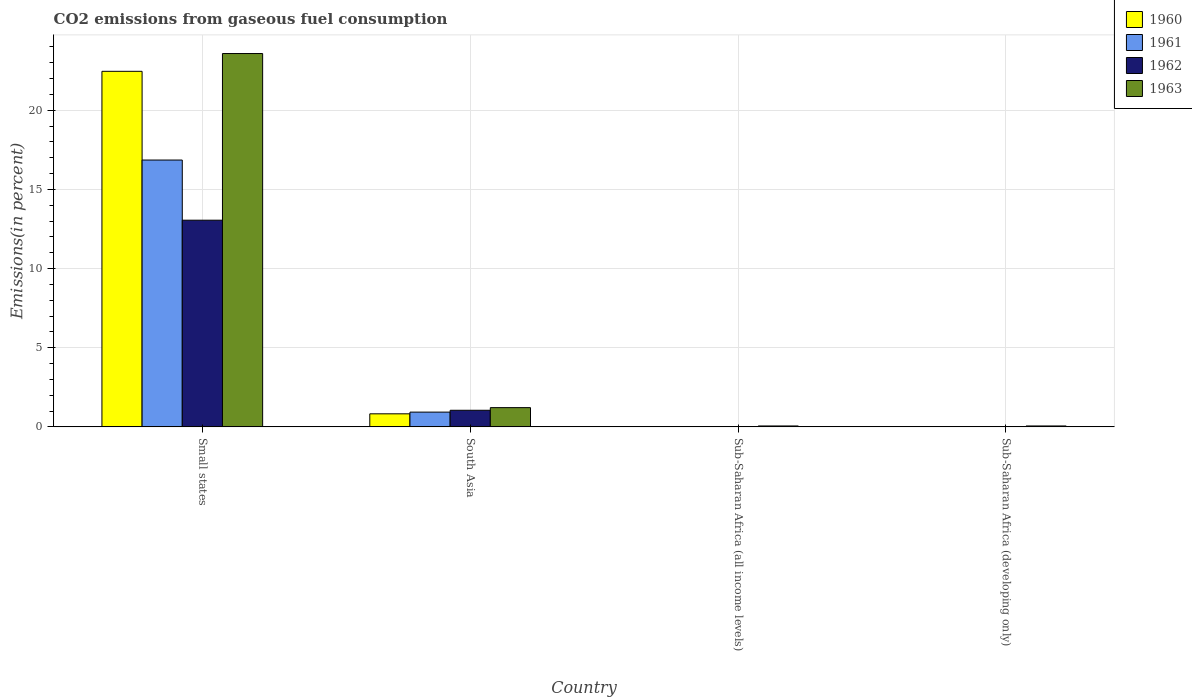How many different coloured bars are there?
Provide a short and direct response. 4. How many groups of bars are there?
Give a very brief answer. 4. Are the number of bars on each tick of the X-axis equal?
Your response must be concise. Yes. How many bars are there on the 2nd tick from the left?
Make the answer very short. 4. What is the label of the 1st group of bars from the left?
Your answer should be very brief. Small states. In how many cases, is the number of bars for a given country not equal to the number of legend labels?
Offer a terse response. 0. What is the total CO2 emitted in 1962 in Small states?
Provide a succinct answer. 13.06. Across all countries, what is the maximum total CO2 emitted in 1963?
Give a very brief answer. 23.59. Across all countries, what is the minimum total CO2 emitted in 1961?
Offer a very short reply. 0.01. In which country was the total CO2 emitted in 1960 maximum?
Keep it short and to the point. Small states. In which country was the total CO2 emitted in 1963 minimum?
Give a very brief answer. Sub-Saharan Africa (all income levels). What is the total total CO2 emitted in 1963 in the graph?
Your answer should be compact. 24.92. What is the difference between the total CO2 emitted in 1960 in South Asia and that in Sub-Saharan Africa (all income levels)?
Give a very brief answer. 0.81. What is the difference between the total CO2 emitted in 1961 in Sub-Saharan Africa (all income levels) and the total CO2 emitted in 1960 in Small states?
Offer a very short reply. -22.45. What is the average total CO2 emitted in 1961 per country?
Offer a terse response. 4.45. What is the difference between the total CO2 emitted of/in 1962 and total CO2 emitted of/in 1960 in Sub-Saharan Africa (developing only)?
Make the answer very short. 0. In how many countries, is the total CO2 emitted in 1962 greater than 13 %?
Offer a terse response. 1. What is the ratio of the total CO2 emitted in 1961 in Small states to that in Sub-Saharan Africa (all income levels)?
Provide a succinct answer. 1414.45. Is the difference between the total CO2 emitted in 1962 in South Asia and Sub-Saharan Africa (developing only) greater than the difference between the total CO2 emitted in 1960 in South Asia and Sub-Saharan Africa (developing only)?
Offer a very short reply. Yes. What is the difference between the highest and the second highest total CO2 emitted in 1960?
Keep it short and to the point. 0.81. What is the difference between the highest and the lowest total CO2 emitted in 1961?
Provide a succinct answer. 16.85. In how many countries, is the total CO2 emitted in 1962 greater than the average total CO2 emitted in 1962 taken over all countries?
Your response must be concise. 1. What does the 3rd bar from the left in Sub-Saharan Africa (all income levels) represents?
Provide a succinct answer. 1962. What does the 4th bar from the right in South Asia represents?
Offer a terse response. 1960. Is it the case that in every country, the sum of the total CO2 emitted in 1963 and total CO2 emitted in 1961 is greater than the total CO2 emitted in 1960?
Your answer should be very brief. Yes. How many bars are there?
Make the answer very short. 16. Does the graph contain any zero values?
Provide a succinct answer. No. Does the graph contain grids?
Your answer should be very brief. Yes. Where does the legend appear in the graph?
Ensure brevity in your answer.  Top right. What is the title of the graph?
Provide a short and direct response. CO2 emissions from gaseous fuel consumption. Does "1971" appear as one of the legend labels in the graph?
Offer a terse response. No. What is the label or title of the X-axis?
Give a very brief answer. Country. What is the label or title of the Y-axis?
Ensure brevity in your answer.  Emissions(in percent). What is the Emissions(in percent) in 1960 in Small states?
Your response must be concise. 22.46. What is the Emissions(in percent) in 1961 in Small states?
Keep it short and to the point. 16.86. What is the Emissions(in percent) of 1962 in Small states?
Provide a succinct answer. 13.06. What is the Emissions(in percent) of 1963 in Small states?
Offer a very short reply. 23.59. What is the Emissions(in percent) of 1960 in South Asia?
Provide a short and direct response. 0.82. What is the Emissions(in percent) of 1961 in South Asia?
Provide a short and direct response. 0.93. What is the Emissions(in percent) of 1962 in South Asia?
Your response must be concise. 1.05. What is the Emissions(in percent) in 1963 in South Asia?
Your response must be concise. 1.22. What is the Emissions(in percent) in 1960 in Sub-Saharan Africa (all income levels)?
Offer a terse response. 0.01. What is the Emissions(in percent) of 1961 in Sub-Saharan Africa (all income levels)?
Your answer should be compact. 0.01. What is the Emissions(in percent) in 1962 in Sub-Saharan Africa (all income levels)?
Provide a short and direct response. 0.01. What is the Emissions(in percent) in 1963 in Sub-Saharan Africa (all income levels)?
Provide a short and direct response. 0.06. What is the Emissions(in percent) of 1960 in Sub-Saharan Africa (developing only)?
Give a very brief answer. 0.01. What is the Emissions(in percent) of 1961 in Sub-Saharan Africa (developing only)?
Provide a succinct answer. 0.01. What is the Emissions(in percent) of 1962 in Sub-Saharan Africa (developing only)?
Provide a short and direct response. 0.01. What is the Emissions(in percent) in 1963 in Sub-Saharan Africa (developing only)?
Your response must be concise. 0.06. Across all countries, what is the maximum Emissions(in percent) in 1960?
Give a very brief answer. 22.46. Across all countries, what is the maximum Emissions(in percent) of 1961?
Your answer should be compact. 16.86. Across all countries, what is the maximum Emissions(in percent) in 1962?
Keep it short and to the point. 13.06. Across all countries, what is the maximum Emissions(in percent) in 1963?
Ensure brevity in your answer.  23.59. Across all countries, what is the minimum Emissions(in percent) in 1960?
Your answer should be compact. 0.01. Across all countries, what is the minimum Emissions(in percent) in 1961?
Provide a succinct answer. 0.01. Across all countries, what is the minimum Emissions(in percent) of 1962?
Make the answer very short. 0.01. Across all countries, what is the minimum Emissions(in percent) in 1963?
Keep it short and to the point. 0.06. What is the total Emissions(in percent) in 1960 in the graph?
Ensure brevity in your answer.  23.31. What is the total Emissions(in percent) in 1961 in the graph?
Offer a very short reply. 17.81. What is the total Emissions(in percent) in 1962 in the graph?
Give a very brief answer. 14.13. What is the total Emissions(in percent) of 1963 in the graph?
Your answer should be very brief. 24.92. What is the difference between the Emissions(in percent) of 1960 in Small states and that in South Asia?
Give a very brief answer. 21.64. What is the difference between the Emissions(in percent) in 1961 in Small states and that in South Asia?
Give a very brief answer. 15.93. What is the difference between the Emissions(in percent) in 1962 in Small states and that in South Asia?
Offer a very short reply. 12.01. What is the difference between the Emissions(in percent) of 1963 in Small states and that in South Asia?
Your answer should be compact. 22.37. What is the difference between the Emissions(in percent) of 1960 in Small states and that in Sub-Saharan Africa (all income levels)?
Your answer should be compact. 22.45. What is the difference between the Emissions(in percent) in 1961 in Small states and that in Sub-Saharan Africa (all income levels)?
Your answer should be compact. 16.85. What is the difference between the Emissions(in percent) in 1962 in Small states and that in Sub-Saharan Africa (all income levels)?
Keep it short and to the point. 13.04. What is the difference between the Emissions(in percent) of 1963 in Small states and that in Sub-Saharan Africa (all income levels)?
Ensure brevity in your answer.  23.53. What is the difference between the Emissions(in percent) in 1960 in Small states and that in Sub-Saharan Africa (developing only)?
Your answer should be very brief. 22.45. What is the difference between the Emissions(in percent) of 1961 in Small states and that in Sub-Saharan Africa (developing only)?
Provide a short and direct response. 16.85. What is the difference between the Emissions(in percent) of 1962 in Small states and that in Sub-Saharan Africa (developing only)?
Ensure brevity in your answer.  13.04. What is the difference between the Emissions(in percent) of 1963 in Small states and that in Sub-Saharan Africa (developing only)?
Provide a short and direct response. 23.53. What is the difference between the Emissions(in percent) in 1960 in South Asia and that in Sub-Saharan Africa (all income levels)?
Provide a succinct answer. 0.81. What is the difference between the Emissions(in percent) in 1961 in South Asia and that in Sub-Saharan Africa (all income levels)?
Keep it short and to the point. 0.92. What is the difference between the Emissions(in percent) of 1962 in South Asia and that in Sub-Saharan Africa (all income levels)?
Offer a very short reply. 1.03. What is the difference between the Emissions(in percent) in 1963 in South Asia and that in Sub-Saharan Africa (all income levels)?
Ensure brevity in your answer.  1.16. What is the difference between the Emissions(in percent) in 1960 in South Asia and that in Sub-Saharan Africa (developing only)?
Offer a very short reply. 0.81. What is the difference between the Emissions(in percent) of 1961 in South Asia and that in Sub-Saharan Africa (developing only)?
Your answer should be compact. 0.92. What is the difference between the Emissions(in percent) of 1962 in South Asia and that in Sub-Saharan Africa (developing only)?
Ensure brevity in your answer.  1.03. What is the difference between the Emissions(in percent) in 1963 in South Asia and that in Sub-Saharan Africa (developing only)?
Ensure brevity in your answer.  1.16. What is the difference between the Emissions(in percent) of 1960 in Sub-Saharan Africa (all income levels) and that in Sub-Saharan Africa (developing only)?
Your answer should be very brief. -0. What is the difference between the Emissions(in percent) of 1962 in Sub-Saharan Africa (all income levels) and that in Sub-Saharan Africa (developing only)?
Offer a very short reply. -0. What is the difference between the Emissions(in percent) of 1960 in Small states and the Emissions(in percent) of 1961 in South Asia?
Keep it short and to the point. 21.53. What is the difference between the Emissions(in percent) in 1960 in Small states and the Emissions(in percent) in 1962 in South Asia?
Your response must be concise. 21.41. What is the difference between the Emissions(in percent) in 1960 in Small states and the Emissions(in percent) in 1963 in South Asia?
Provide a short and direct response. 21.25. What is the difference between the Emissions(in percent) in 1961 in Small states and the Emissions(in percent) in 1962 in South Asia?
Offer a terse response. 15.81. What is the difference between the Emissions(in percent) of 1961 in Small states and the Emissions(in percent) of 1963 in South Asia?
Your response must be concise. 15.64. What is the difference between the Emissions(in percent) in 1962 in Small states and the Emissions(in percent) in 1963 in South Asia?
Keep it short and to the point. 11.84. What is the difference between the Emissions(in percent) of 1960 in Small states and the Emissions(in percent) of 1961 in Sub-Saharan Africa (all income levels)?
Provide a succinct answer. 22.45. What is the difference between the Emissions(in percent) in 1960 in Small states and the Emissions(in percent) in 1962 in Sub-Saharan Africa (all income levels)?
Ensure brevity in your answer.  22.45. What is the difference between the Emissions(in percent) in 1960 in Small states and the Emissions(in percent) in 1963 in Sub-Saharan Africa (all income levels)?
Keep it short and to the point. 22.4. What is the difference between the Emissions(in percent) in 1961 in Small states and the Emissions(in percent) in 1962 in Sub-Saharan Africa (all income levels)?
Give a very brief answer. 16.84. What is the difference between the Emissions(in percent) of 1961 in Small states and the Emissions(in percent) of 1963 in Sub-Saharan Africa (all income levels)?
Your answer should be compact. 16.8. What is the difference between the Emissions(in percent) in 1962 in Small states and the Emissions(in percent) in 1963 in Sub-Saharan Africa (all income levels)?
Keep it short and to the point. 13. What is the difference between the Emissions(in percent) of 1960 in Small states and the Emissions(in percent) of 1961 in Sub-Saharan Africa (developing only)?
Provide a succinct answer. 22.45. What is the difference between the Emissions(in percent) of 1960 in Small states and the Emissions(in percent) of 1962 in Sub-Saharan Africa (developing only)?
Provide a short and direct response. 22.45. What is the difference between the Emissions(in percent) in 1960 in Small states and the Emissions(in percent) in 1963 in Sub-Saharan Africa (developing only)?
Provide a short and direct response. 22.4. What is the difference between the Emissions(in percent) of 1961 in Small states and the Emissions(in percent) of 1962 in Sub-Saharan Africa (developing only)?
Provide a succinct answer. 16.84. What is the difference between the Emissions(in percent) of 1961 in Small states and the Emissions(in percent) of 1963 in Sub-Saharan Africa (developing only)?
Give a very brief answer. 16.8. What is the difference between the Emissions(in percent) of 1962 in Small states and the Emissions(in percent) of 1963 in Sub-Saharan Africa (developing only)?
Keep it short and to the point. 13. What is the difference between the Emissions(in percent) of 1960 in South Asia and the Emissions(in percent) of 1961 in Sub-Saharan Africa (all income levels)?
Provide a succinct answer. 0.81. What is the difference between the Emissions(in percent) in 1960 in South Asia and the Emissions(in percent) in 1962 in Sub-Saharan Africa (all income levels)?
Ensure brevity in your answer.  0.81. What is the difference between the Emissions(in percent) of 1960 in South Asia and the Emissions(in percent) of 1963 in Sub-Saharan Africa (all income levels)?
Your answer should be compact. 0.77. What is the difference between the Emissions(in percent) of 1961 in South Asia and the Emissions(in percent) of 1962 in Sub-Saharan Africa (all income levels)?
Your answer should be very brief. 0.92. What is the difference between the Emissions(in percent) in 1961 in South Asia and the Emissions(in percent) in 1963 in Sub-Saharan Africa (all income levels)?
Your answer should be very brief. 0.87. What is the difference between the Emissions(in percent) in 1962 in South Asia and the Emissions(in percent) in 1963 in Sub-Saharan Africa (all income levels)?
Offer a very short reply. 0.99. What is the difference between the Emissions(in percent) in 1960 in South Asia and the Emissions(in percent) in 1961 in Sub-Saharan Africa (developing only)?
Provide a succinct answer. 0.81. What is the difference between the Emissions(in percent) of 1960 in South Asia and the Emissions(in percent) of 1962 in Sub-Saharan Africa (developing only)?
Ensure brevity in your answer.  0.81. What is the difference between the Emissions(in percent) of 1960 in South Asia and the Emissions(in percent) of 1963 in Sub-Saharan Africa (developing only)?
Give a very brief answer. 0.77. What is the difference between the Emissions(in percent) of 1961 in South Asia and the Emissions(in percent) of 1962 in Sub-Saharan Africa (developing only)?
Make the answer very short. 0.92. What is the difference between the Emissions(in percent) in 1961 in South Asia and the Emissions(in percent) in 1963 in Sub-Saharan Africa (developing only)?
Make the answer very short. 0.87. What is the difference between the Emissions(in percent) in 1962 in South Asia and the Emissions(in percent) in 1963 in Sub-Saharan Africa (developing only)?
Ensure brevity in your answer.  0.99. What is the difference between the Emissions(in percent) in 1960 in Sub-Saharan Africa (all income levels) and the Emissions(in percent) in 1961 in Sub-Saharan Africa (developing only)?
Provide a succinct answer. 0. What is the difference between the Emissions(in percent) in 1960 in Sub-Saharan Africa (all income levels) and the Emissions(in percent) in 1962 in Sub-Saharan Africa (developing only)?
Your answer should be compact. -0. What is the difference between the Emissions(in percent) in 1960 in Sub-Saharan Africa (all income levels) and the Emissions(in percent) in 1963 in Sub-Saharan Africa (developing only)?
Provide a short and direct response. -0.05. What is the difference between the Emissions(in percent) of 1961 in Sub-Saharan Africa (all income levels) and the Emissions(in percent) of 1962 in Sub-Saharan Africa (developing only)?
Offer a terse response. -0. What is the difference between the Emissions(in percent) of 1961 in Sub-Saharan Africa (all income levels) and the Emissions(in percent) of 1963 in Sub-Saharan Africa (developing only)?
Offer a very short reply. -0.05. What is the difference between the Emissions(in percent) in 1962 in Sub-Saharan Africa (all income levels) and the Emissions(in percent) in 1963 in Sub-Saharan Africa (developing only)?
Ensure brevity in your answer.  -0.04. What is the average Emissions(in percent) in 1960 per country?
Offer a very short reply. 5.83. What is the average Emissions(in percent) in 1961 per country?
Your response must be concise. 4.45. What is the average Emissions(in percent) of 1962 per country?
Make the answer very short. 3.53. What is the average Emissions(in percent) of 1963 per country?
Your answer should be compact. 6.23. What is the difference between the Emissions(in percent) of 1960 and Emissions(in percent) of 1961 in Small states?
Provide a short and direct response. 5.6. What is the difference between the Emissions(in percent) of 1960 and Emissions(in percent) of 1962 in Small states?
Your answer should be very brief. 9.41. What is the difference between the Emissions(in percent) of 1960 and Emissions(in percent) of 1963 in Small states?
Keep it short and to the point. -1.12. What is the difference between the Emissions(in percent) of 1961 and Emissions(in percent) of 1962 in Small states?
Make the answer very short. 3.8. What is the difference between the Emissions(in percent) of 1961 and Emissions(in percent) of 1963 in Small states?
Offer a terse response. -6.73. What is the difference between the Emissions(in percent) in 1962 and Emissions(in percent) in 1963 in Small states?
Your response must be concise. -10.53. What is the difference between the Emissions(in percent) in 1960 and Emissions(in percent) in 1961 in South Asia?
Your response must be concise. -0.11. What is the difference between the Emissions(in percent) of 1960 and Emissions(in percent) of 1962 in South Asia?
Your answer should be compact. -0.22. What is the difference between the Emissions(in percent) of 1960 and Emissions(in percent) of 1963 in South Asia?
Offer a very short reply. -0.39. What is the difference between the Emissions(in percent) of 1961 and Emissions(in percent) of 1962 in South Asia?
Ensure brevity in your answer.  -0.12. What is the difference between the Emissions(in percent) of 1961 and Emissions(in percent) of 1963 in South Asia?
Offer a terse response. -0.28. What is the difference between the Emissions(in percent) in 1962 and Emissions(in percent) in 1963 in South Asia?
Your answer should be very brief. -0.17. What is the difference between the Emissions(in percent) of 1960 and Emissions(in percent) of 1961 in Sub-Saharan Africa (all income levels)?
Your answer should be very brief. 0. What is the difference between the Emissions(in percent) of 1960 and Emissions(in percent) of 1962 in Sub-Saharan Africa (all income levels)?
Keep it short and to the point. -0. What is the difference between the Emissions(in percent) of 1960 and Emissions(in percent) of 1963 in Sub-Saharan Africa (all income levels)?
Provide a succinct answer. -0.05. What is the difference between the Emissions(in percent) in 1961 and Emissions(in percent) in 1962 in Sub-Saharan Africa (all income levels)?
Make the answer very short. -0. What is the difference between the Emissions(in percent) of 1961 and Emissions(in percent) of 1963 in Sub-Saharan Africa (all income levels)?
Give a very brief answer. -0.05. What is the difference between the Emissions(in percent) in 1962 and Emissions(in percent) in 1963 in Sub-Saharan Africa (all income levels)?
Your answer should be compact. -0.04. What is the difference between the Emissions(in percent) in 1960 and Emissions(in percent) in 1962 in Sub-Saharan Africa (developing only)?
Your answer should be very brief. -0. What is the difference between the Emissions(in percent) in 1960 and Emissions(in percent) in 1963 in Sub-Saharan Africa (developing only)?
Your answer should be compact. -0.05. What is the difference between the Emissions(in percent) in 1961 and Emissions(in percent) in 1962 in Sub-Saharan Africa (developing only)?
Give a very brief answer. -0. What is the difference between the Emissions(in percent) of 1961 and Emissions(in percent) of 1963 in Sub-Saharan Africa (developing only)?
Give a very brief answer. -0.05. What is the difference between the Emissions(in percent) of 1962 and Emissions(in percent) of 1963 in Sub-Saharan Africa (developing only)?
Offer a very short reply. -0.04. What is the ratio of the Emissions(in percent) of 1960 in Small states to that in South Asia?
Offer a very short reply. 27.26. What is the ratio of the Emissions(in percent) of 1961 in Small states to that in South Asia?
Your response must be concise. 18.09. What is the ratio of the Emissions(in percent) of 1962 in Small states to that in South Asia?
Your answer should be compact. 12.45. What is the ratio of the Emissions(in percent) of 1963 in Small states to that in South Asia?
Make the answer very short. 19.41. What is the ratio of the Emissions(in percent) in 1960 in Small states to that in Sub-Saharan Africa (all income levels)?
Offer a terse response. 1801.95. What is the ratio of the Emissions(in percent) in 1961 in Small states to that in Sub-Saharan Africa (all income levels)?
Make the answer very short. 1414.45. What is the ratio of the Emissions(in percent) of 1962 in Small states to that in Sub-Saharan Africa (all income levels)?
Ensure brevity in your answer.  907.48. What is the ratio of the Emissions(in percent) in 1963 in Small states to that in Sub-Saharan Africa (all income levels)?
Provide a short and direct response. 409.19. What is the ratio of the Emissions(in percent) in 1960 in Small states to that in Sub-Saharan Africa (developing only)?
Ensure brevity in your answer.  1801.61. What is the ratio of the Emissions(in percent) of 1961 in Small states to that in Sub-Saharan Africa (developing only)?
Provide a succinct answer. 1414.2. What is the ratio of the Emissions(in percent) in 1962 in Small states to that in Sub-Saharan Africa (developing only)?
Make the answer very short. 907.33. What is the ratio of the Emissions(in percent) of 1963 in Small states to that in Sub-Saharan Africa (developing only)?
Your response must be concise. 409.09. What is the ratio of the Emissions(in percent) of 1960 in South Asia to that in Sub-Saharan Africa (all income levels)?
Your response must be concise. 66.11. What is the ratio of the Emissions(in percent) of 1961 in South Asia to that in Sub-Saharan Africa (all income levels)?
Provide a succinct answer. 78.18. What is the ratio of the Emissions(in percent) of 1962 in South Asia to that in Sub-Saharan Africa (all income levels)?
Keep it short and to the point. 72.9. What is the ratio of the Emissions(in percent) of 1963 in South Asia to that in Sub-Saharan Africa (all income levels)?
Your answer should be very brief. 21.08. What is the ratio of the Emissions(in percent) in 1960 in South Asia to that in Sub-Saharan Africa (developing only)?
Provide a succinct answer. 66.1. What is the ratio of the Emissions(in percent) in 1961 in South Asia to that in Sub-Saharan Africa (developing only)?
Offer a very short reply. 78.17. What is the ratio of the Emissions(in percent) in 1962 in South Asia to that in Sub-Saharan Africa (developing only)?
Your answer should be very brief. 72.89. What is the ratio of the Emissions(in percent) in 1963 in South Asia to that in Sub-Saharan Africa (developing only)?
Provide a short and direct response. 21.08. What is the ratio of the Emissions(in percent) of 1963 in Sub-Saharan Africa (all income levels) to that in Sub-Saharan Africa (developing only)?
Ensure brevity in your answer.  1. What is the difference between the highest and the second highest Emissions(in percent) in 1960?
Provide a succinct answer. 21.64. What is the difference between the highest and the second highest Emissions(in percent) of 1961?
Offer a very short reply. 15.93. What is the difference between the highest and the second highest Emissions(in percent) of 1962?
Ensure brevity in your answer.  12.01. What is the difference between the highest and the second highest Emissions(in percent) in 1963?
Ensure brevity in your answer.  22.37. What is the difference between the highest and the lowest Emissions(in percent) of 1960?
Offer a terse response. 22.45. What is the difference between the highest and the lowest Emissions(in percent) in 1961?
Ensure brevity in your answer.  16.85. What is the difference between the highest and the lowest Emissions(in percent) in 1962?
Your answer should be compact. 13.04. What is the difference between the highest and the lowest Emissions(in percent) in 1963?
Provide a short and direct response. 23.53. 